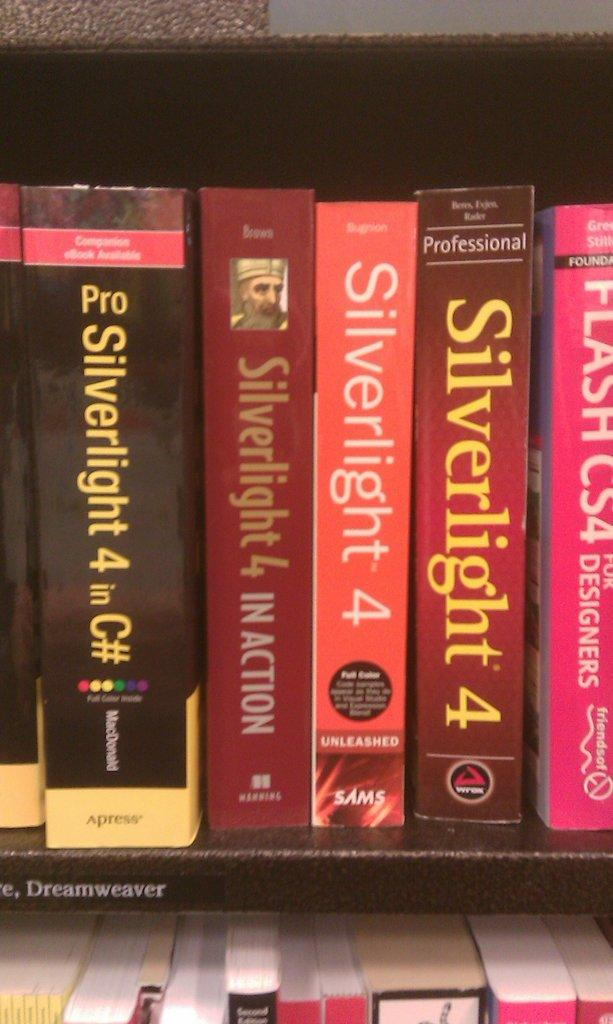<image>
Relay a brief, clear account of the picture shown. A shelf fill of books that are mostly titled SIlverlight 4. 